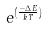<formula> <loc_0><loc_0><loc_500><loc_500>e ^ { ( \frac { - \Delta E } { k T } ) }</formula> 